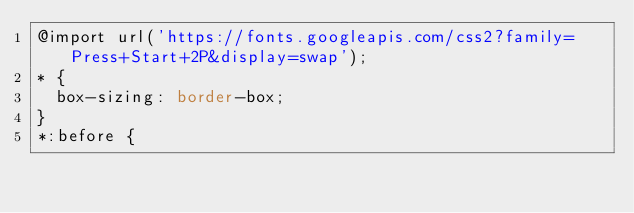<code> <loc_0><loc_0><loc_500><loc_500><_CSS_>@import url('https://fonts.googleapis.com/css2?family=Press+Start+2P&display=swap');
* {
  box-sizing: border-box;
}
*:before {</code> 